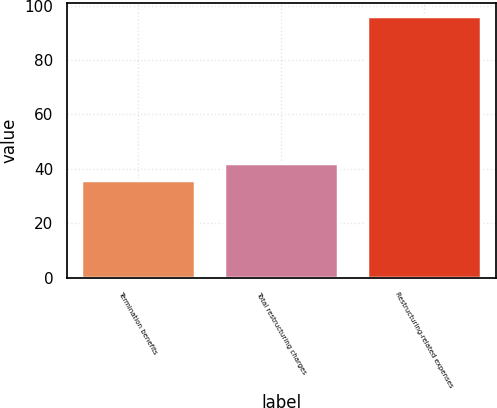Convert chart. <chart><loc_0><loc_0><loc_500><loc_500><bar_chart><fcel>Termination benefits<fcel>Total restructuring charges<fcel>Restructuring-related expenses<nl><fcel>36<fcel>42<fcel>96<nl></chart> 